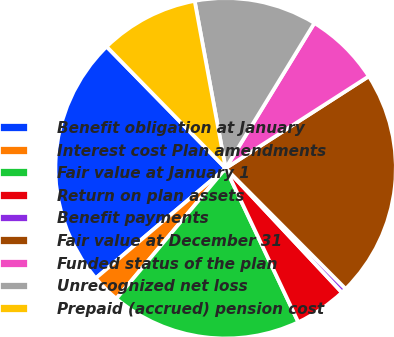Convert chart. <chart><loc_0><loc_0><loc_500><loc_500><pie_chart><fcel>Benefit obligation at January<fcel>Interest cost Plan amendments<fcel>Fair value at January 1<fcel>Return on plan assets<fcel>Benefit payments<fcel>Fair value at December 31<fcel>Funded status of the plan<fcel>Unrecognized net loss<fcel>Prepaid (accrued) pension cost<nl><fcel>23.85%<fcel>2.72%<fcel>18.12%<fcel>4.95%<fcel>0.49%<fcel>21.62%<fcel>7.18%<fcel>11.64%<fcel>9.41%<nl></chart> 